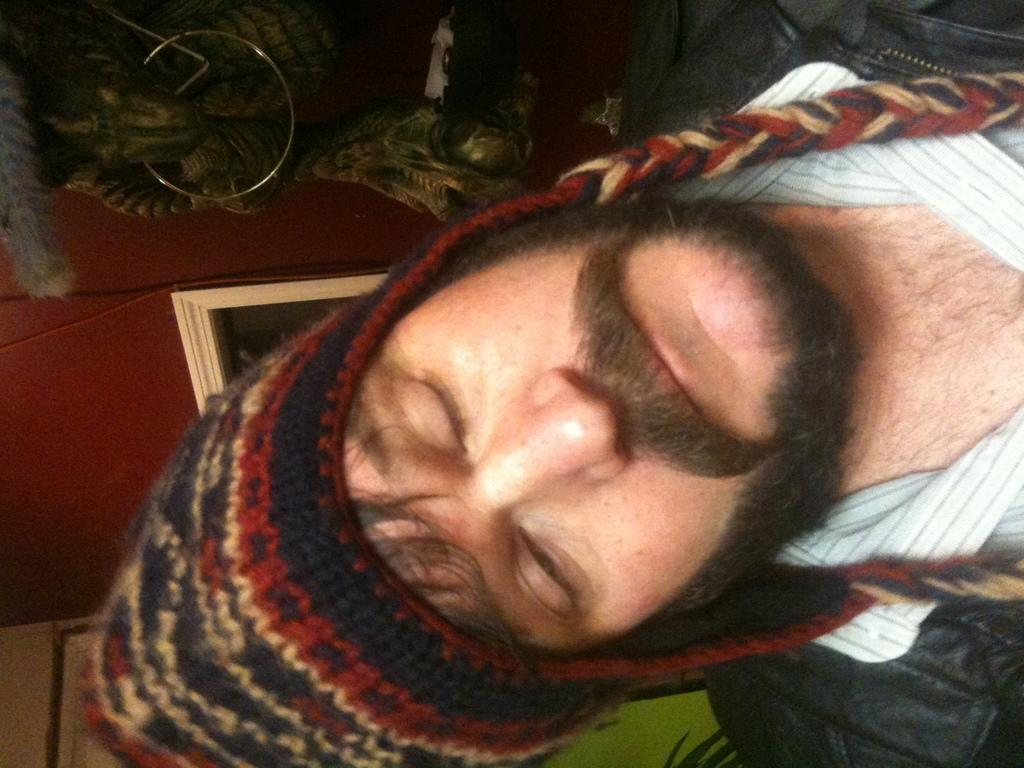Who or what is on the right side of the image? There is a person on the right side of the image. What is on the left side of the image? There is a wall on the left side of the image. Can you describe the object on the top of the image? Unfortunately, the provided facts do not give any information about the object on the top of the image. How much dust is visible on the person's clothes in the image? There is no information about dust or the person's clothes in the provided facts, so it cannot be determined from the image. 